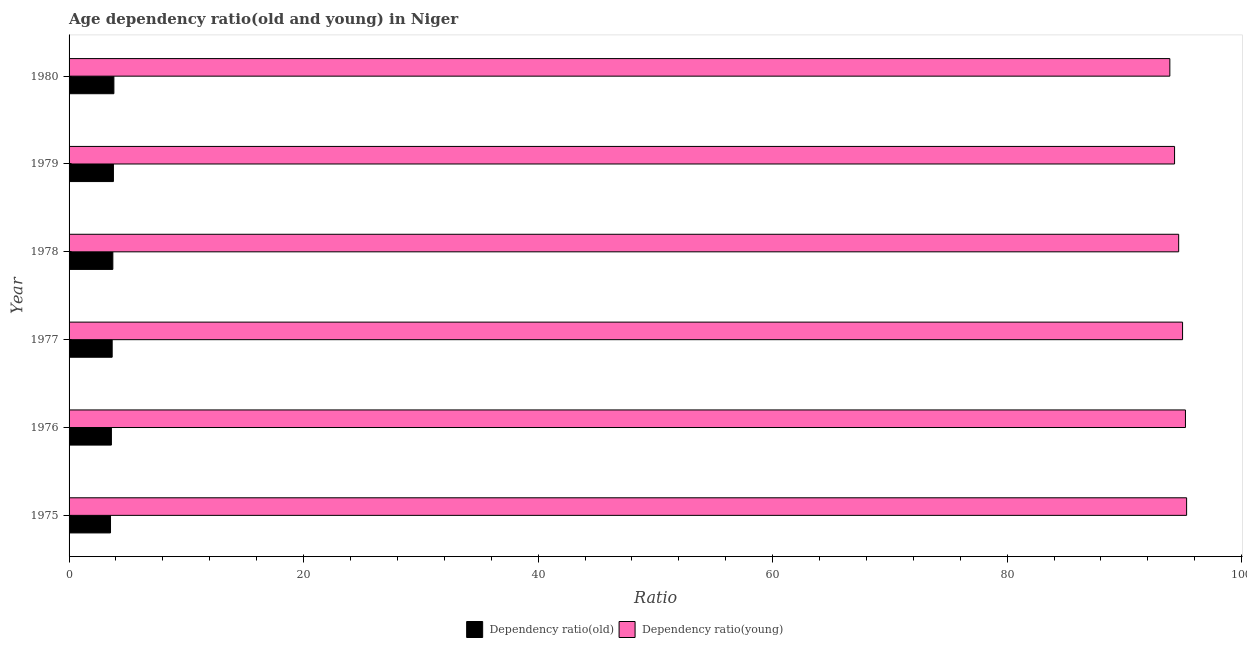How many different coloured bars are there?
Your answer should be compact. 2. How many groups of bars are there?
Make the answer very short. 6. Are the number of bars per tick equal to the number of legend labels?
Your response must be concise. Yes. Are the number of bars on each tick of the Y-axis equal?
Offer a very short reply. Yes. How many bars are there on the 3rd tick from the top?
Ensure brevity in your answer.  2. What is the label of the 6th group of bars from the top?
Offer a terse response. 1975. What is the age dependency ratio(young) in 1977?
Keep it short and to the point. 94.96. Across all years, what is the maximum age dependency ratio(old)?
Your answer should be very brief. 3.82. Across all years, what is the minimum age dependency ratio(young)?
Your answer should be very brief. 93.87. In which year was the age dependency ratio(young) maximum?
Offer a terse response. 1975. In which year was the age dependency ratio(old) minimum?
Your answer should be very brief. 1975. What is the total age dependency ratio(young) in the graph?
Offer a very short reply. 568.23. What is the difference between the age dependency ratio(old) in 1979 and that in 1980?
Your response must be concise. -0.04. What is the difference between the age dependency ratio(young) in 1975 and the age dependency ratio(old) in 1980?
Provide a short and direct response. 91.48. What is the average age dependency ratio(young) per year?
Offer a very short reply. 94.7. In the year 1975, what is the difference between the age dependency ratio(old) and age dependency ratio(young)?
Ensure brevity in your answer.  -91.77. In how many years, is the age dependency ratio(old) greater than 28 ?
Provide a succinct answer. 0. Is the difference between the age dependency ratio(old) in 1976 and 1978 greater than the difference between the age dependency ratio(young) in 1976 and 1978?
Ensure brevity in your answer.  No. What is the difference between the highest and the second highest age dependency ratio(old)?
Your answer should be compact. 0.04. What is the difference between the highest and the lowest age dependency ratio(old)?
Your answer should be compact. 0.29. What does the 2nd bar from the top in 1977 represents?
Provide a succinct answer. Dependency ratio(old). What does the 2nd bar from the bottom in 1978 represents?
Your answer should be very brief. Dependency ratio(young). What is the difference between two consecutive major ticks on the X-axis?
Keep it short and to the point. 20. Are the values on the major ticks of X-axis written in scientific E-notation?
Give a very brief answer. No. Does the graph contain any zero values?
Ensure brevity in your answer.  No. Where does the legend appear in the graph?
Offer a very short reply. Bottom center. How are the legend labels stacked?
Your answer should be very brief. Horizontal. What is the title of the graph?
Your response must be concise. Age dependency ratio(old and young) in Niger. Does "Commercial service exports" appear as one of the legend labels in the graph?
Offer a very short reply. No. What is the label or title of the X-axis?
Ensure brevity in your answer.  Ratio. What is the Ratio in Dependency ratio(old) in 1975?
Ensure brevity in your answer.  3.53. What is the Ratio of Dependency ratio(young) in 1975?
Your answer should be very brief. 95.3. What is the Ratio of Dependency ratio(old) in 1976?
Your answer should be very brief. 3.61. What is the Ratio of Dependency ratio(young) in 1976?
Offer a very short reply. 95.2. What is the Ratio in Dependency ratio(old) in 1977?
Ensure brevity in your answer.  3.68. What is the Ratio of Dependency ratio(young) in 1977?
Give a very brief answer. 94.96. What is the Ratio in Dependency ratio(old) in 1978?
Your answer should be compact. 3.73. What is the Ratio in Dependency ratio(young) in 1978?
Your answer should be very brief. 94.62. What is the Ratio in Dependency ratio(old) in 1979?
Your answer should be compact. 3.78. What is the Ratio in Dependency ratio(young) in 1979?
Your answer should be compact. 94.27. What is the Ratio in Dependency ratio(old) in 1980?
Keep it short and to the point. 3.82. What is the Ratio of Dependency ratio(young) in 1980?
Your response must be concise. 93.87. Across all years, what is the maximum Ratio in Dependency ratio(old)?
Provide a succinct answer. 3.82. Across all years, what is the maximum Ratio in Dependency ratio(young)?
Offer a terse response. 95.3. Across all years, what is the minimum Ratio of Dependency ratio(old)?
Make the answer very short. 3.53. Across all years, what is the minimum Ratio of Dependency ratio(young)?
Make the answer very short. 93.87. What is the total Ratio in Dependency ratio(old) in the graph?
Ensure brevity in your answer.  22.16. What is the total Ratio of Dependency ratio(young) in the graph?
Offer a terse response. 568.23. What is the difference between the Ratio in Dependency ratio(old) in 1975 and that in 1976?
Provide a succinct answer. -0.08. What is the difference between the Ratio in Dependency ratio(young) in 1975 and that in 1976?
Your answer should be compact. 0.1. What is the difference between the Ratio of Dependency ratio(old) in 1975 and that in 1977?
Your response must be concise. -0.14. What is the difference between the Ratio in Dependency ratio(young) in 1975 and that in 1977?
Offer a very short reply. 0.35. What is the difference between the Ratio in Dependency ratio(old) in 1975 and that in 1978?
Provide a short and direct response. -0.2. What is the difference between the Ratio of Dependency ratio(young) in 1975 and that in 1978?
Your answer should be very brief. 0.68. What is the difference between the Ratio of Dependency ratio(old) in 1975 and that in 1979?
Provide a short and direct response. -0.25. What is the difference between the Ratio in Dependency ratio(young) in 1975 and that in 1979?
Make the answer very short. 1.03. What is the difference between the Ratio of Dependency ratio(old) in 1975 and that in 1980?
Your answer should be very brief. -0.29. What is the difference between the Ratio of Dependency ratio(young) in 1975 and that in 1980?
Give a very brief answer. 1.43. What is the difference between the Ratio in Dependency ratio(old) in 1976 and that in 1977?
Provide a short and direct response. -0.07. What is the difference between the Ratio of Dependency ratio(young) in 1976 and that in 1977?
Provide a succinct answer. 0.25. What is the difference between the Ratio of Dependency ratio(old) in 1976 and that in 1978?
Offer a terse response. -0.12. What is the difference between the Ratio in Dependency ratio(young) in 1976 and that in 1978?
Provide a succinct answer. 0.58. What is the difference between the Ratio in Dependency ratio(old) in 1976 and that in 1979?
Give a very brief answer. -0.17. What is the difference between the Ratio of Dependency ratio(young) in 1976 and that in 1979?
Your answer should be compact. 0.93. What is the difference between the Ratio in Dependency ratio(old) in 1976 and that in 1980?
Your response must be concise. -0.21. What is the difference between the Ratio in Dependency ratio(young) in 1976 and that in 1980?
Your answer should be compact. 1.33. What is the difference between the Ratio in Dependency ratio(old) in 1977 and that in 1978?
Keep it short and to the point. -0.06. What is the difference between the Ratio of Dependency ratio(young) in 1977 and that in 1978?
Give a very brief answer. 0.33. What is the difference between the Ratio in Dependency ratio(old) in 1977 and that in 1979?
Provide a succinct answer. -0.11. What is the difference between the Ratio of Dependency ratio(young) in 1977 and that in 1979?
Ensure brevity in your answer.  0.68. What is the difference between the Ratio of Dependency ratio(old) in 1977 and that in 1980?
Provide a succinct answer. -0.15. What is the difference between the Ratio in Dependency ratio(young) in 1977 and that in 1980?
Ensure brevity in your answer.  1.08. What is the difference between the Ratio of Dependency ratio(old) in 1978 and that in 1979?
Your answer should be very brief. -0.05. What is the difference between the Ratio of Dependency ratio(young) in 1978 and that in 1979?
Your response must be concise. 0.35. What is the difference between the Ratio in Dependency ratio(old) in 1978 and that in 1980?
Provide a short and direct response. -0.09. What is the difference between the Ratio of Dependency ratio(young) in 1978 and that in 1980?
Offer a terse response. 0.75. What is the difference between the Ratio in Dependency ratio(old) in 1979 and that in 1980?
Your response must be concise. -0.04. What is the difference between the Ratio in Dependency ratio(young) in 1979 and that in 1980?
Give a very brief answer. 0.4. What is the difference between the Ratio in Dependency ratio(old) in 1975 and the Ratio in Dependency ratio(young) in 1976?
Make the answer very short. -91.67. What is the difference between the Ratio of Dependency ratio(old) in 1975 and the Ratio of Dependency ratio(young) in 1977?
Your answer should be compact. -91.42. What is the difference between the Ratio in Dependency ratio(old) in 1975 and the Ratio in Dependency ratio(young) in 1978?
Offer a very short reply. -91.09. What is the difference between the Ratio of Dependency ratio(old) in 1975 and the Ratio of Dependency ratio(young) in 1979?
Offer a very short reply. -90.74. What is the difference between the Ratio in Dependency ratio(old) in 1975 and the Ratio in Dependency ratio(young) in 1980?
Give a very brief answer. -90.34. What is the difference between the Ratio in Dependency ratio(old) in 1976 and the Ratio in Dependency ratio(young) in 1977?
Keep it short and to the point. -91.35. What is the difference between the Ratio of Dependency ratio(old) in 1976 and the Ratio of Dependency ratio(young) in 1978?
Ensure brevity in your answer.  -91.01. What is the difference between the Ratio of Dependency ratio(old) in 1976 and the Ratio of Dependency ratio(young) in 1979?
Offer a very short reply. -90.66. What is the difference between the Ratio in Dependency ratio(old) in 1976 and the Ratio in Dependency ratio(young) in 1980?
Offer a terse response. -90.26. What is the difference between the Ratio of Dependency ratio(old) in 1977 and the Ratio of Dependency ratio(young) in 1978?
Ensure brevity in your answer.  -90.95. What is the difference between the Ratio of Dependency ratio(old) in 1977 and the Ratio of Dependency ratio(young) in 1979?
Provide a short and direct response. -90.6. What is the difference between the Ratio in Dependency ratio(old) in 1977 and the Ratio in Dependency ratio(young) in 1980?
Offer a terse response. -90.2. What is the difference between the Ratio in Dependency ratio(old) in 1978 and the Ratio in Dependency ratio(young) in 1979?
Ensure brevity in your answer.  -90.54. What is the difference between the Ratio in Dependency ratio(old) in 1978 and the Ratio in Dependency ratio(young) in 1980?
Ensure brevity in your answer.  -90.14. What is the difference between the Ratio of Dependency ratio(old) in 1979 and the Ratio of Dependency ratio(young) in 1980?
Offer a very short reply. -90.09. What is the average Ratio in Dependency ratio(old) per year?
Ensure brevity in your answer.  3.69. What is the average Ratio of Dependency ratio(young) per year?
Your answer should be very brief. 94.71. In the year 1975, what is the difference between the Ratio of Dependency ratio(old) and Ratio of Dependency ratio(young)?
Your response must be concise. -91.77. In the year 1976, what is the difference between the Ratio in Dependency ratio(old) and Ratio in Dependency ratio(young)?
Give a very brief answer. -91.59. In the year 1977, what is the difference between the Ratio in Dependency ratio(old) and Ratio in Dependency ratio(young)?
Ensure brevity in your answer.  -91.28. In the year 1978, what is the difference between the Ratio in Dependency ratio(old) and Ratio in Dependency ratio(young)?
Your answer should be compact. -90.89. In the year 1979, what is the difference between the Ratio of Dependency ratio(old) and Ratio of Dependency ratio(young)?
Provide a succinct answer. -90.49. In the year 1980, what is the difference between the Ratio of Dependency ratio(old) and Ratio of Dependency ratio(young)?
Offer a very short reply. -90.05. What is the ratio of the Ratio in Dependency ratio(old) in 1975 to that in 1976?
Give a very brief answer. 0.98. What is the ratio of the Ratio in Dependency ratio(old) in 1975 to that in 1977?
Keep it short and to the point. 0.96. What is the ratio of the Ratio of Dependency ratio(old) in 1975 to that in 1978?
Offer a terse response. 0.95. What is the ratio of the Ratio of Dependency ratio(young) in 1975 to that in 1978?
Provide a short and direct response. 1.01. What is the ratio of the Ratio in Dependency ratio(old) in 1975 to that in 1979?
Your answer should be compact. 0.93. What is the ratio of the Ratio of Dependency ratio(young) in 1975 to that in 1979?
Make the answer very short. 1.01. What is the ratio of the Ratio of Dependency ratio(old) in 1975 to that in 1980?
Your answer should be compact. 0.92. What is the ratio of the Ratio of Dependency ratio(young) in 1975 to that in 1980?
Make the answer very short. 1.02. What is the ratio of the Ratio in Dependency ratio(old) in 1976 to that in 1977?
Your answer should be very brief. 0.98. What is the ratio of the Ratio of Dependency ratio(old) in 1976 to that in 1978?
Provide a succinct answer. 0.97. What is the ratio of the Ratio in Dependency ratio(old) in 1976 to that in 1979?
Ensure brevity in your answer.  0.95. What is the ratio of the Ratio in Dependency ratio(young) in 1976 to that in 1979?
Your answer should be compact. 1.01. What is the ratio of the Ratio in Dependency ratio(old) in 1976 to that in 1980?
Your response must be concise. 0.94. What is the ratio of the Ratio of Dependency ratio(young) in 1976 to that in 1980?
Offer a terse response. 1.01. What is the ratio of the Ratio of Dependency ratio(old) in 1977 to that in 1978?
Your answer should be compact. 0.98. What is the ratio of the Ratio in Dependency ratio(young) in 1977 to that in 1978?
Offer a terse response. 1. What is the ratio of the Ratio of Dependency ratio(old) in 1977 to that in 1979?
Offer a terse response. 0.97. What is the ratio of the Ratio in Dependency ratio(young) in 1977 to that in 1979?
Offer a very short reply. 1.01. What is the ratio of the Ratio in Dependency ratio(old) in 1977 to that in 1980?
Provide a short and direct response. 0.96. What is the ratio of the Ratio of Dependency ratio(young) in 1977 to that in 1980?
Provide a short and direct response. 1.01. What is the ratio of the Ratio of Dependency ratio(old) in 1978 to that in 1979?
Keep it short and to the point. 0.99. What is the ratio of the Ratio in Dependency ratio(young) in 1978 to that in 1979?
Give a very brief answer. 1. What is the ratio of the Ratio of Dependency ratio(old) in 1978 to that in 1980?
Make the answer very short. 0.98. What is the ratio of the Ratio in Dependency ratio(young) in 1978 to that in 1980?
Provide a succinct answer. 1.01. What is the ratio of the Ratio of Dependency ratio(old) in 1979 to that in 1980?
Give a very brief answer. 0.99. What is the difference between the highest and the second highest Ratio of Dependency ratio(old)?
Provide a succinct answer. 0.04. What is the difference between the highest and the second highest Ratio in Dependency ratio(young)?
Your answer should be compact. 0.1. What is the difference between the highest and the lowest Ratio in Dependency ratio(old)?
Make the answer very short. 0.29. What is the difference between the highest and the lowest Ratio of Dependency ratio(young)?
Give a very brief answer. 1.43. 